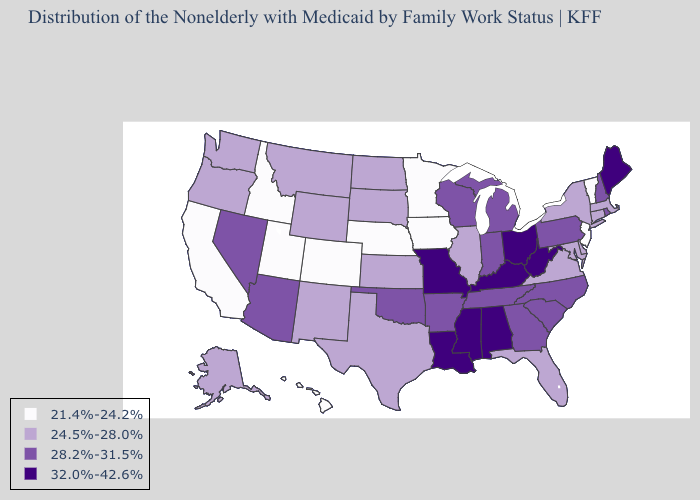Name the states that have a value in the range 28.2%-31.5%?
Give a very brief answer. Arizona, Arkansas, Georgia, Indiana, Michigan, Nevada, New Hampshire, North Carolina, Oklahoma, Pennsylvania, Rhode Island, South Carolina, Tennessee, Wisconsin. Name the states that have a value in the range 24.5%-28.0%?
Write a very short answer. Alaska, Connecticut, Delaware, Florida, Illinois, Kansas, Maryland, Massachusetts, Montana, New Mexico, New York, North Dakota, Oregon, South Dakota, Texas, Virginia, Washington, Wyoming. Name the states that have a value in the range 21.4%-24.2%?
Be succinct. California, Colorado, Hawaii, Idaho, Iowa, Minnesota, Nebraska, New Jersey, Utah, Vermont. What is the lowest value in the Northeast?
Short answer required. 21.4%-24.2%. Does Idaho have the lowest value in the USA?
Give a very brief answer. Yes. Does Kentucky have the highest value in the USA?
Short answer required. Yes. What is the value of Georgia?
Quick response, please. 28.2%-31.5%. Name the states that have a value in the range 28.2%-31.5%?
Keep it brief. Arizona, Arkansas, Georgia, Indiana, Michigan, Nevada, New Hampshire, North Carolina, Oklahoma, Pennsylvania, Rhode Island, South Carolina, Tennessee, Wisconsin. Name the states that have a value in the range 24.5%-28.0%?
Give a very brief answer. Alaska, Connecticut, Delaware, Florida, Illinois, Kansas, Maryland, Massachusetts, Montana, New Mexico, New York, North Dakota, Oregon, South Dakota, Texas, Virginia, Washington, Wyoming. Does New York have the lowest value in the USA?
Give a very brief answer. No. Does West Virginia have the highest value in the USA?
Concise answer only. Yes. What is the value of Pennsylvania?
Be succinct. 28.2%-31.5%. Among the states that border Tennessee , which have the highest value?
Be succinct. Alabama, Kentucky, Mississippi, Missouri. Does the first symbol in the legend represent the smallest category?
Give a very brief answer. Yes. Which states hav the highest value in the MidWest?
Quick response, please. Missouri, Ohio. 